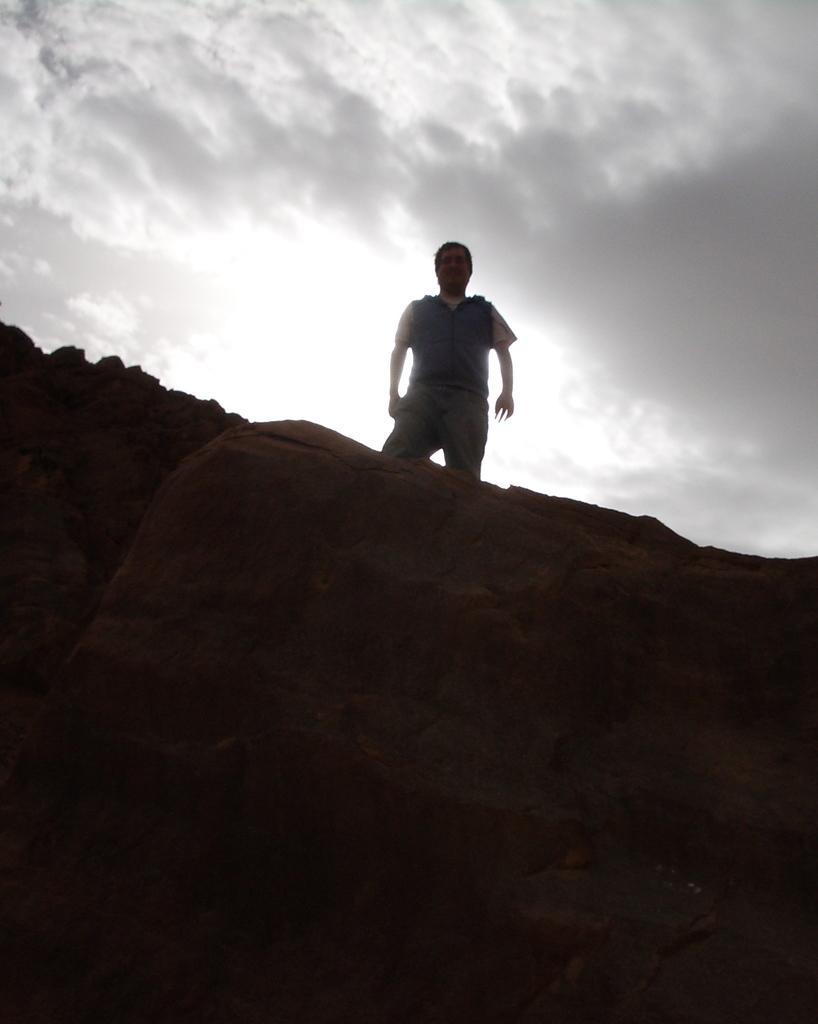Can you describe this image briefly? In this image there is the sky towards the top of the image, there are rocks towards the bottom of the image, there is a man standing on the rock. 